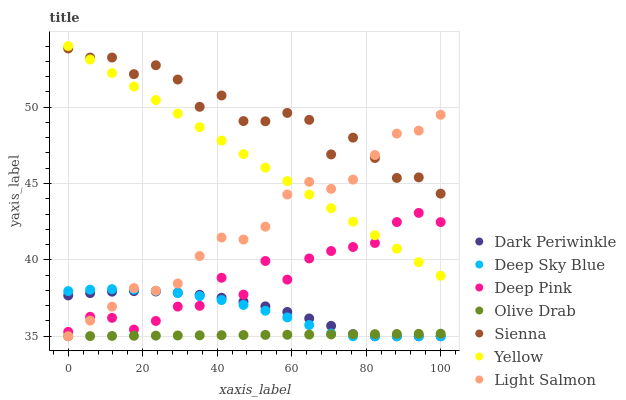Does Olive Drab have the minimum area under the curve?
Answer yes or no. Yes. Does Sienna have the maximum area under the curve?
Answer yes or no. Yes. Does Deep Pink have the minimum area under the curve?
Answer yes or no. No. Does Deep Pink have the maximum area under the curve?
Answer yes or no. No. Is Olive Drab the smoothest?
Answer yes or no. Yes. Is Sienna the roughest?
Answer yes or no. Yes. Is Deep Pink the smoothest?
Answer yes or no. No. Is Deep Pink the roughest?
Answer yes or no. No. Does Light Salmon have the lowest value?
Answer yes or no. Yes. Does Deep Pink have the lowest value?
Answer yes or no. No. Does Yellow have the highest value?
Answer yes or no. Yes. Does Deep Pink have the highest value?
Answer yes or no. No. Is Deep Sky Blue less than Sienna?
Answer yes or no. Yes. Is Yellow greater than Dark Periwinkle?
Answer yes or no. Yes. Does Sienna intersect Yellow?
Answer yes or no. Yes. Is Sienna less than Yellow?
Answer yes or no. No. Is Sienna greater than Yellow?
Answer yes or no. No. Does Deep Sky Blue intersect Sienna?
Answer yes or no. No. 